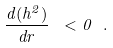Convert formula to latex. <formula><loc_0><loc_0><loc_500><loc_500>\frac { d ( h ^ { 2 } ) } { d r } \ < 0 \ .</formula> 